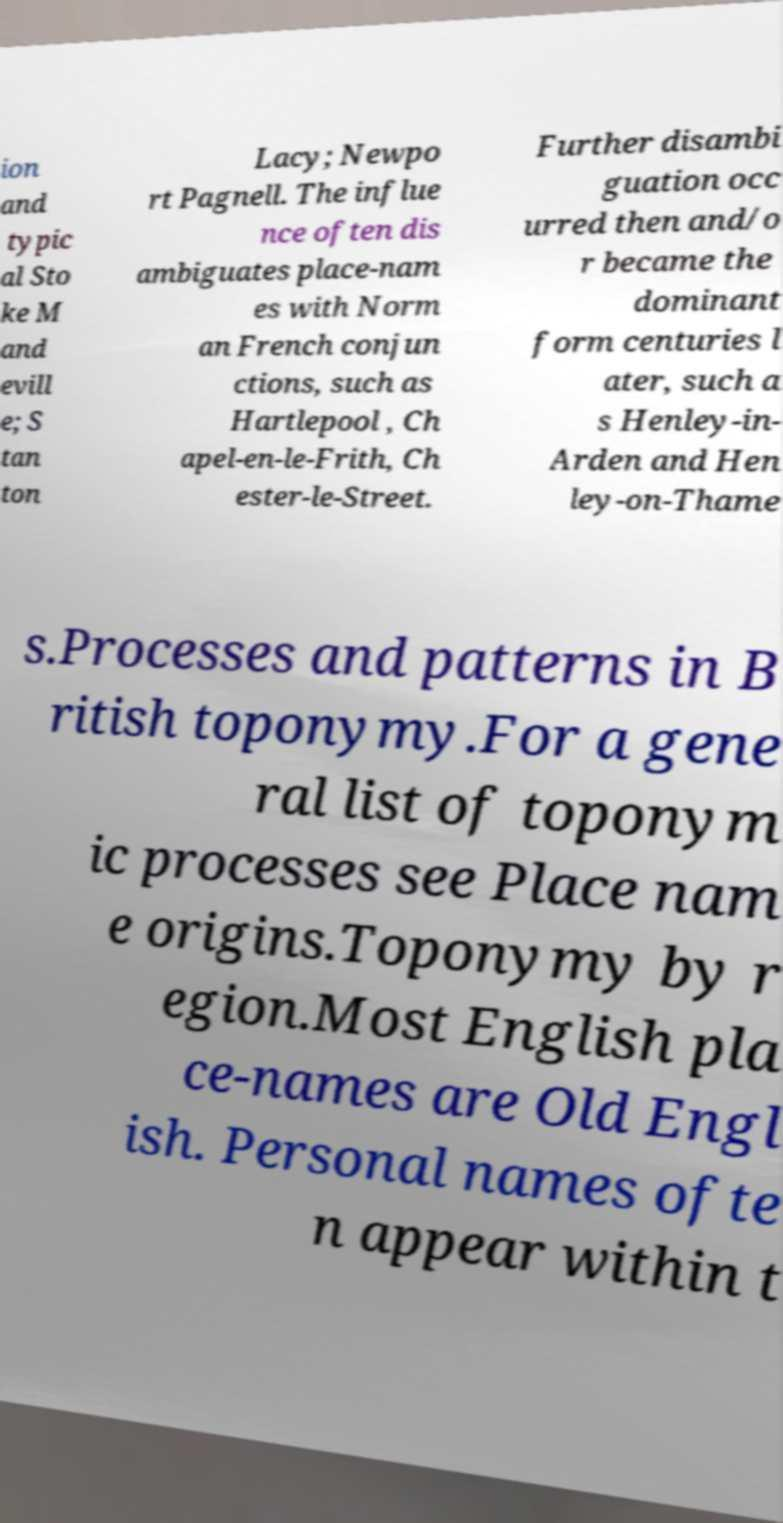What messages or text are displayed in this image? I need them in a readable, typed format. ion and typic al Sto ke M and evill e; S tan ton Lacy; Newpo rt Pagnell. The influe nce often dis ambiguates place-nam es with Norm an French conjun ctions, such as Hartlepool , Ch apel-en-le-Frith, Ch ester-le-Street. Further disambi guation occ urred then and/o r became the dominant form centuries l ater, such a s Henley-in- Arden and Hen ley-on-Thame s.Processes and patterns in B ritish toponymy.For a gene ral list of toponym ic processes see Place nam e origins.Toponymy by r egion.Most English pla ce-names are Old Engl ish. Personal names ofte n appear within t 